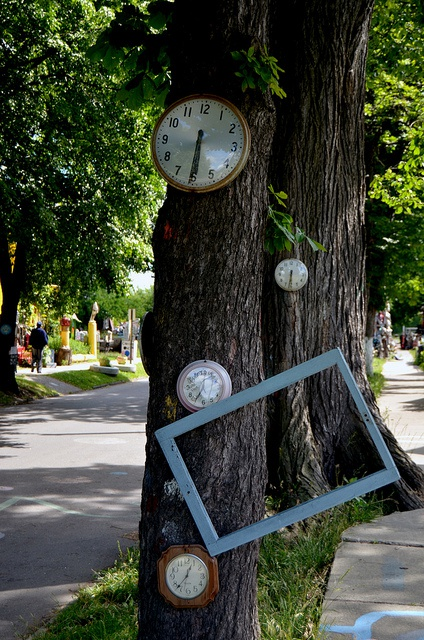Describe the objects in this image and their specific colors. I can see clock in black, gray, darkgray, and darkgreen tones, clock in black, darkgray, gray, and lightblue tones, clock in black, darkgray, and gray tones, clock in black, darkgray, and gray tones, and people in black, gray, and darkgray tones in this image. 